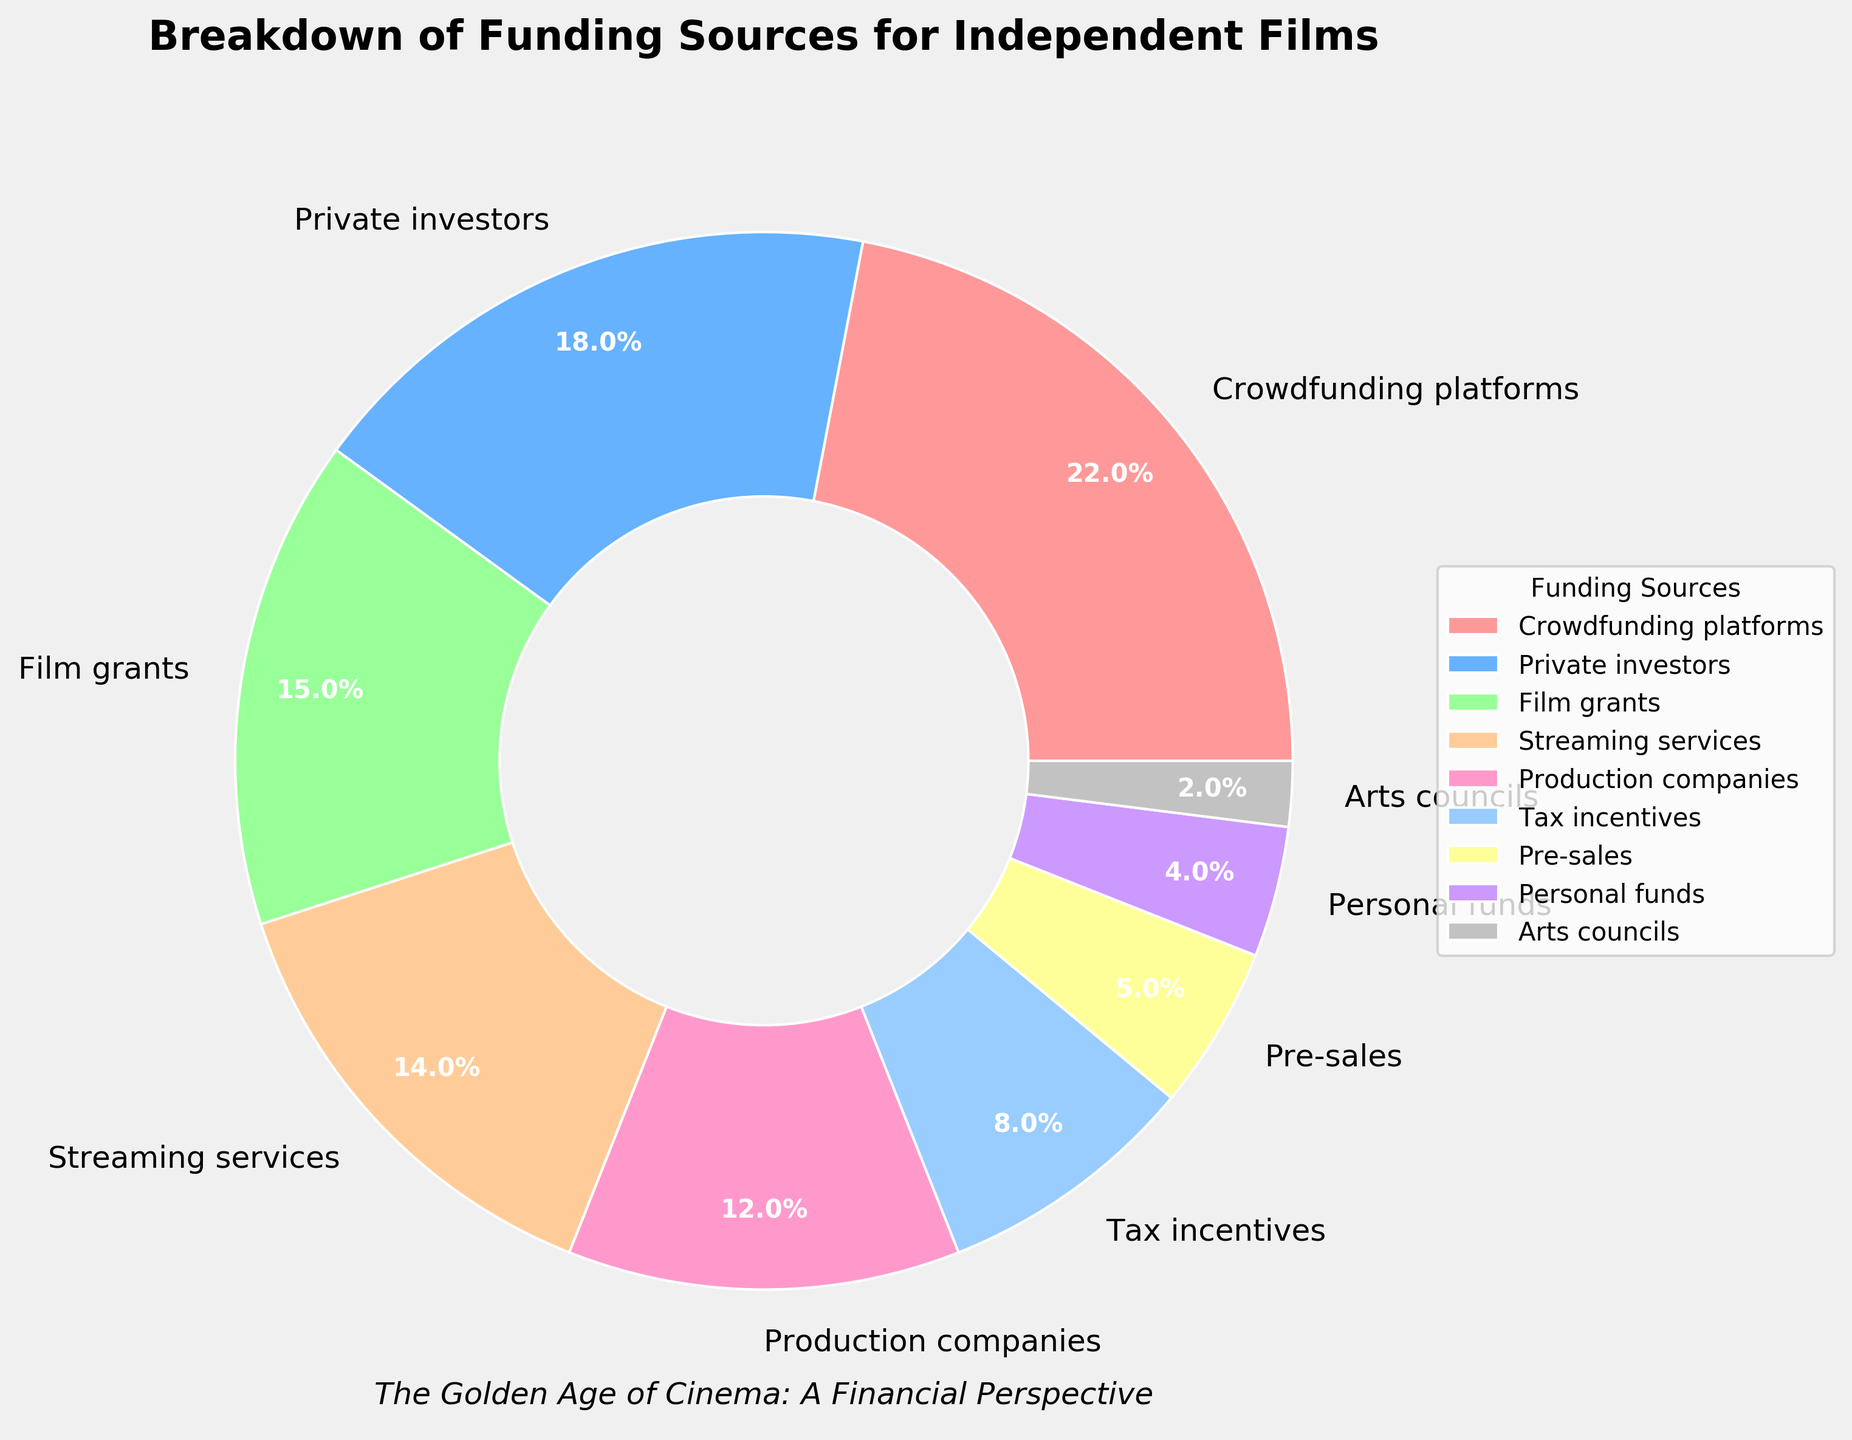Which funding source accounts for the largest percentage of funding for independent films? By looking at the pie chart, the segment occupying the largest area corresponds to "Crowdfunding platforms," which has a percentage label indicating 22%.
Answer: Crowdfunding platforms Which funding source provides more funds: Private investors or Production companies? By comparing the segments of "Private investors" and "Production companies," the pie chart shows that "Private investors" provide 18% of funding, whereas "Production companies" provide 12%.
Answer: Private investors What is the combined percentage of funding from Crowdfunding platforms, Film grants and Streaming services? To find this, add the percentages from Crowdfunding platforms (22%), Film grants (15%), and Streaming services (14%). The combined percentage is 22% + 15% + 14% = 51%.
Answer: 51% Which funding sources contribute the same percentage to independent film funding, and what is this percentage? By examining the pie chart, the categories "Personal funds" and "Arts councils" both contribute 4% and 2% respectively to the funding.
Answer: None Is the percentage contribution from Tax incentives greater than that from Pre-sales? By comparing the segments, the pie chart shows that Tax incentives contribute 8%, while Pre-sales contribute 5%. Therefore, Tax incentives contribute a greater percentage.
Answer: Yes What is the difference in percentage points between the contributions from Private investors and Arts councils? To find this, subtract the percentage of Arts councils (2%) from Private investors (18%): 18% - 2% = 16 percentage points.
Answer: 16 percentage points Which funding source segment is represented by the green color? By referring to the specific colors used in the pie chart, the green color represents "Crowdfunding platforms."
Answer: Crowdfunding platforms Considering only the contributions from Film grants and Pre-sales, what is their average percentage contribution? To find the average percentage, add the contributions from Film grants (15%) and Pre-sales (5%) and divide by 2: (15% + 5%) / 2 = 10%.
Answer: 10% How does the percentage of funding from Crowdfunding platforms compare to that from Streaming services in terms of relative size? By comparing the percentages, Crowdfunding platforms contribute 22% while Streaming services contribute 14%. Thus, Crowdfunding platforms contribute a relatively larger percentage.
Answer: Crowdfunding platforms contribute more How many funding sources contribute less than 10% each to the overall funding? By examining the pie chart, the funding sources that contribute less than 10% are Tax incentives (8%), Pre-sales (5%), Personal funds (4%), and Arts councils (2%). There are 4 categories in total.
Answer: 4 